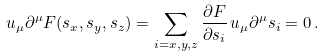Convert formula to latex. <formula><loc_0><loc_0><loc_500><loc_500>u _ { \mu } \partial ^ { \mu } F ( s _ { x } , s _ { y } , s _ { z } ) = \sum _ { i = x , y , z } \frac { \partial F } { \partial s _ { i } } \, u _ { \mu } \partial ^ { \mu } s _ { i } = 0 \, .</formula> 